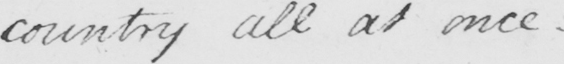Please transcribe the handwritten text in this image. country all at once  _ 